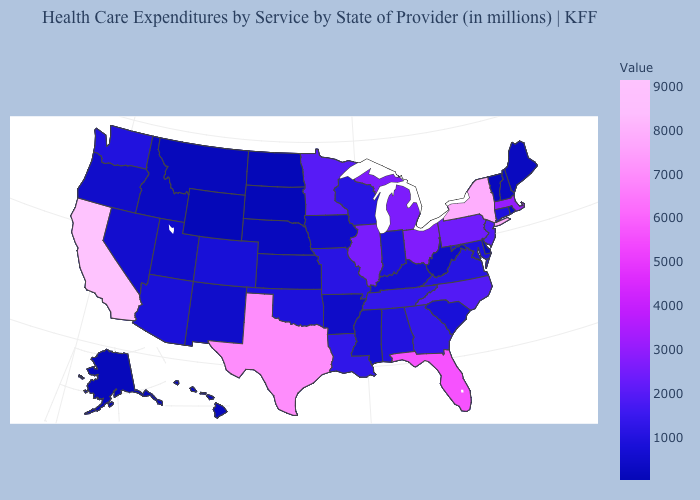Which states hav the highest value in the West?
Give a very brief answer. California. Is the legend a continuous bar?
Short answer required. Yes. Does Illinois have the lowest value in the MidWest?
Be succinct. No. Which states have the highest value in the USA?
Write a very short answer. California. Does Maine have the lowest value in the Northeast?
Short answer required. No. 